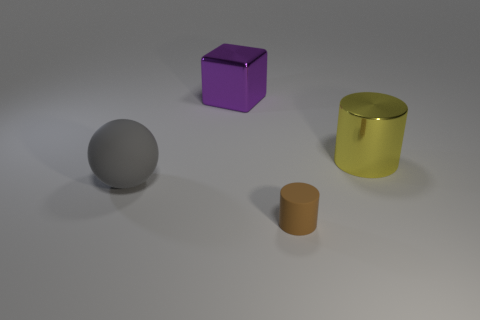Subtract all blocks. How many objects are left? 3 Add 1 big gray balls. How many objects exist? 5 Subtract 1 spheres. How many spheres are left? 0 Add 3 tiny objects. How many tiny objects exist? 4 Subtract 0 gray cubes. How many objects are left? 4 Subtract all green cylinders. Subtract all brown blocks. How many cylinders are left? 2 Subtract all cyan blocks. How many brown cylinders are left? 1 Subtract all gray things. Subtract all metallic things. How many objects are left? 1 Add 4 purple things. How many purple things are left? 5 